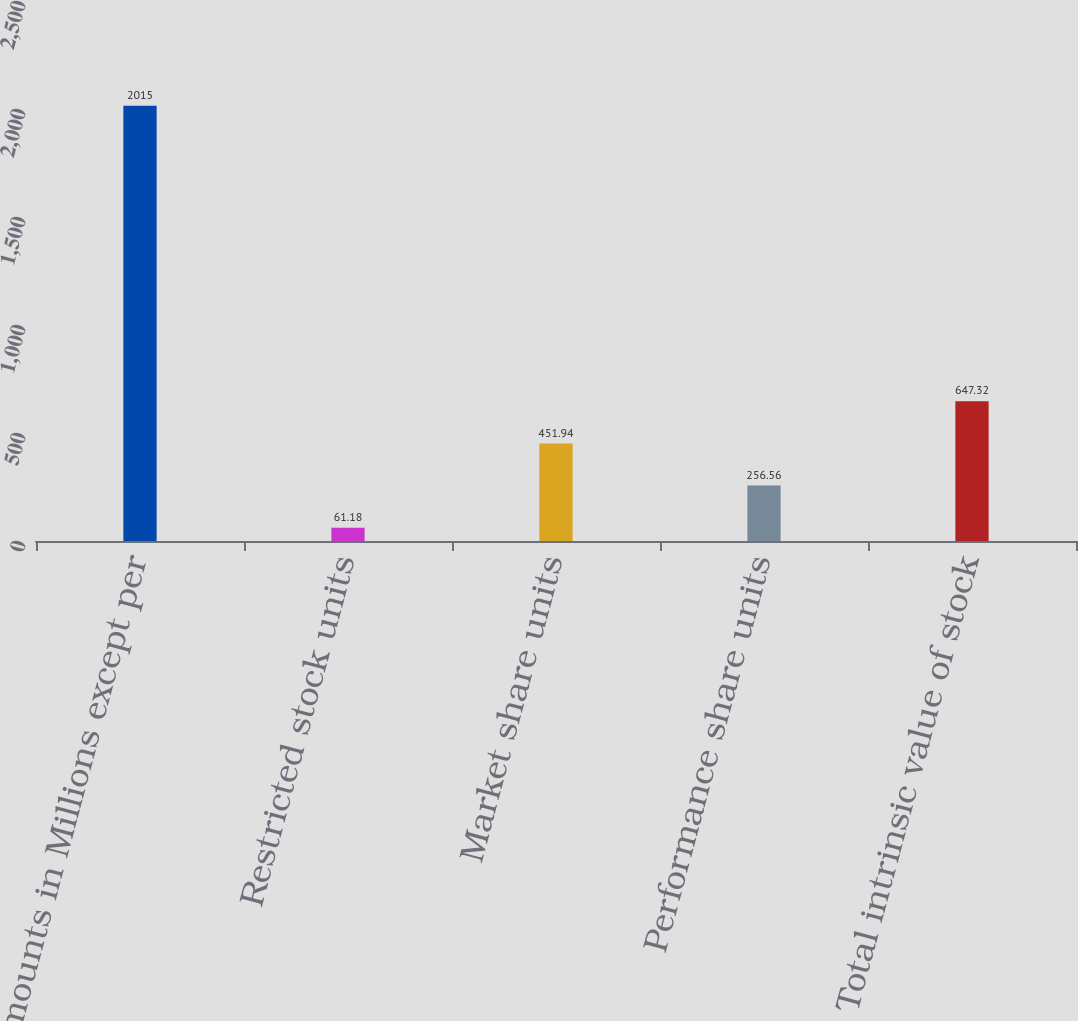Convert chart. <chart><loc_0><loc_0><loc_500><loc_500><bar_chart><fcel>Amounts in Millions except per<fcel>Restricted stock units<fcel>Market share units<fcel>Performance share units<fcel>Total intrinsic value of stock<nl><fcel>2015<fcel>61.18<fcel>451.94<fcel>256.56<fcel>647.32<nl></chart> 